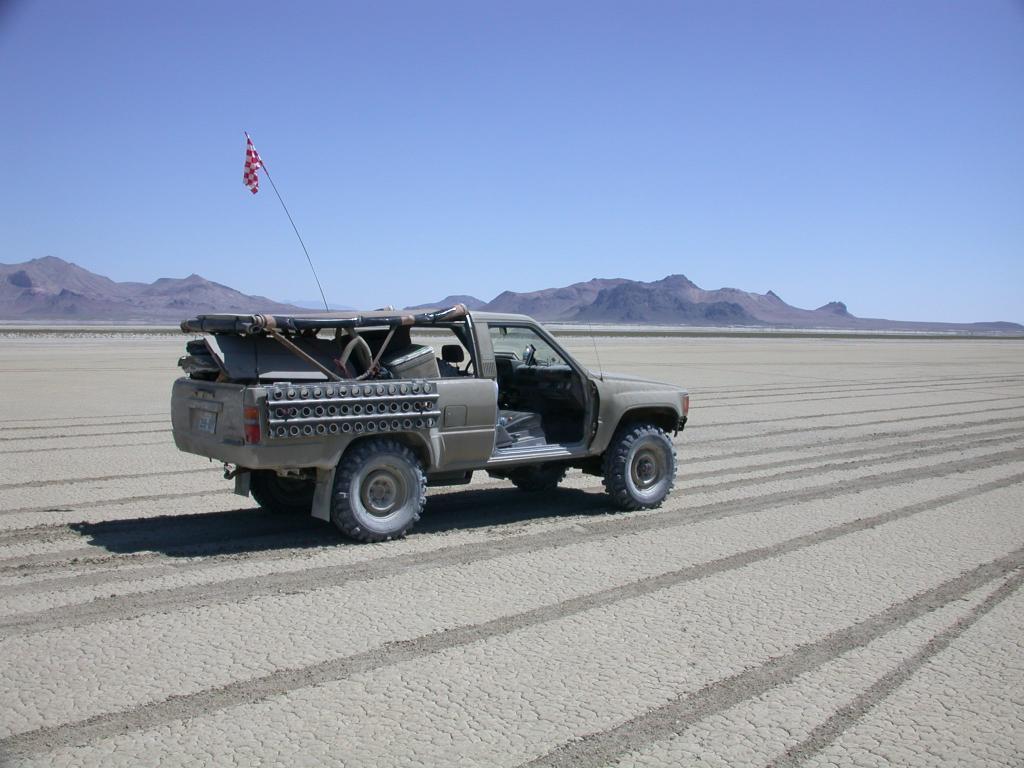How would you summarize this image in a sentence or two? In this image there is a truck on the ground. On it there is a flag. In the background there are hills. The sky is clear. 